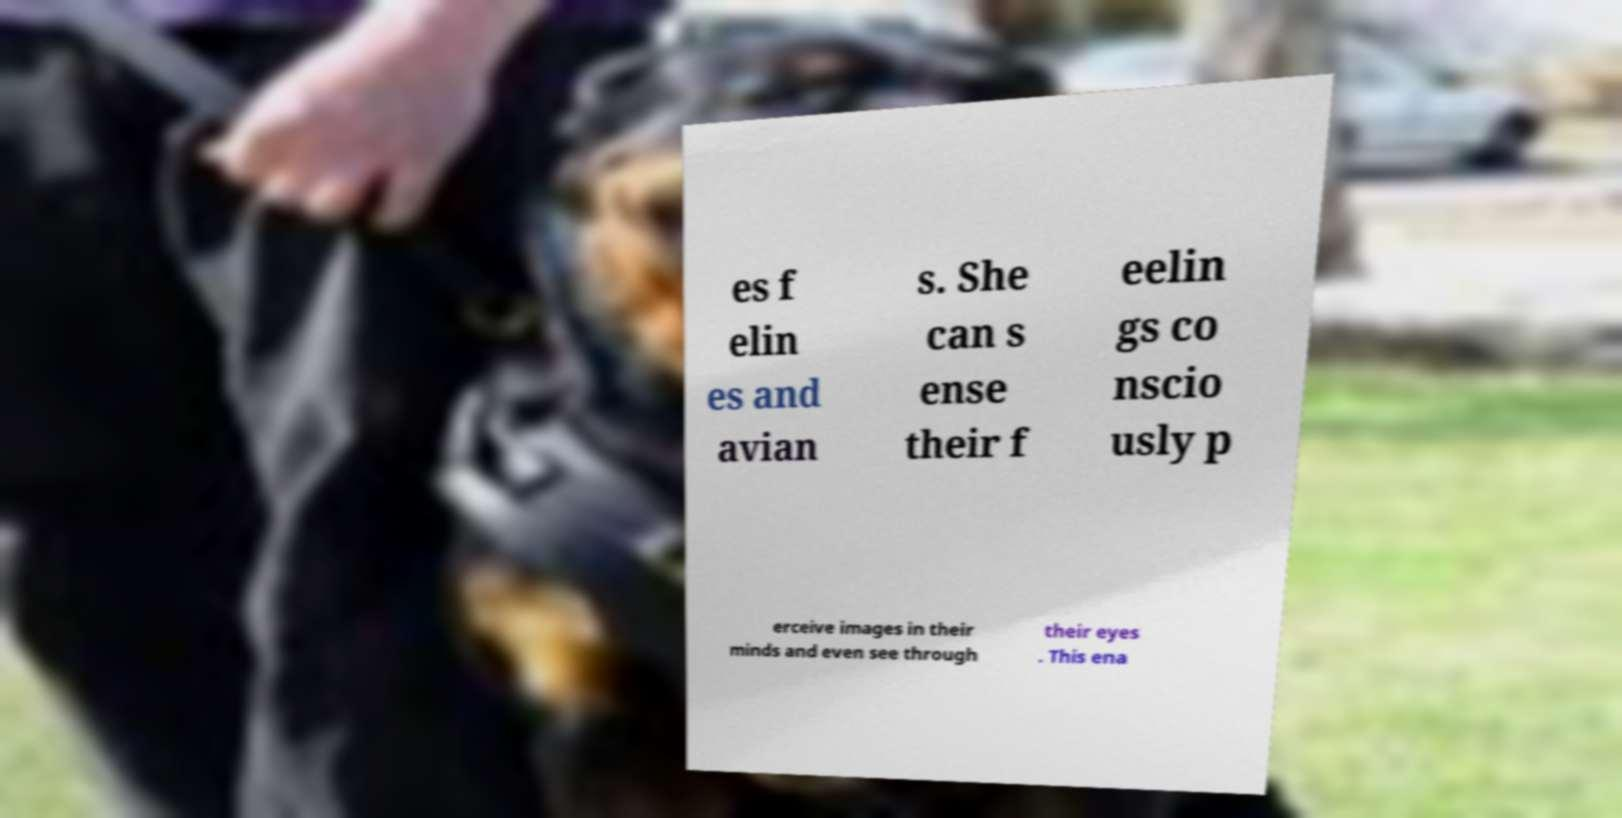For documentation purposes, I need the text within this image transcribed. Could you provide that? es f elin es and avian s. She can s ense their f eelin gs co nscio usly p erceive images in their minds and even see through their eyes . This ena 